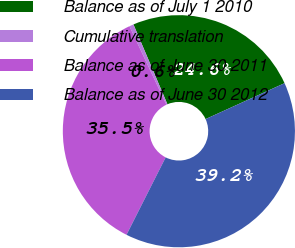Convert chart to OTSL. <chart><loc_0><loc_0><loc_500><loc_500><pie_chart><fcel>Balance as of July 1 2010<fcel>Cumulative translation<fcel>Balance as of June 30 2011<fcel>Balance as of June 30 2012<nl><fcel>24.61%<fcel>0.6%<fcel>35.54%<fcel>39.24%<nl></chart> 